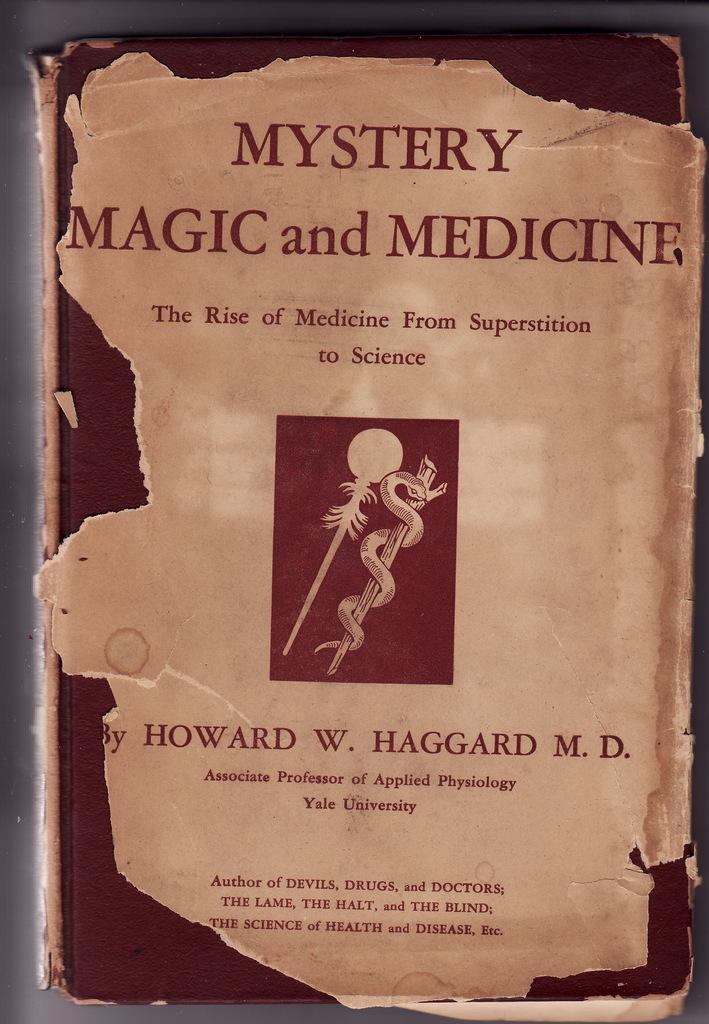How many people are shown in the picture?
Offer a terse response. Answering does not require reading text in the image. 